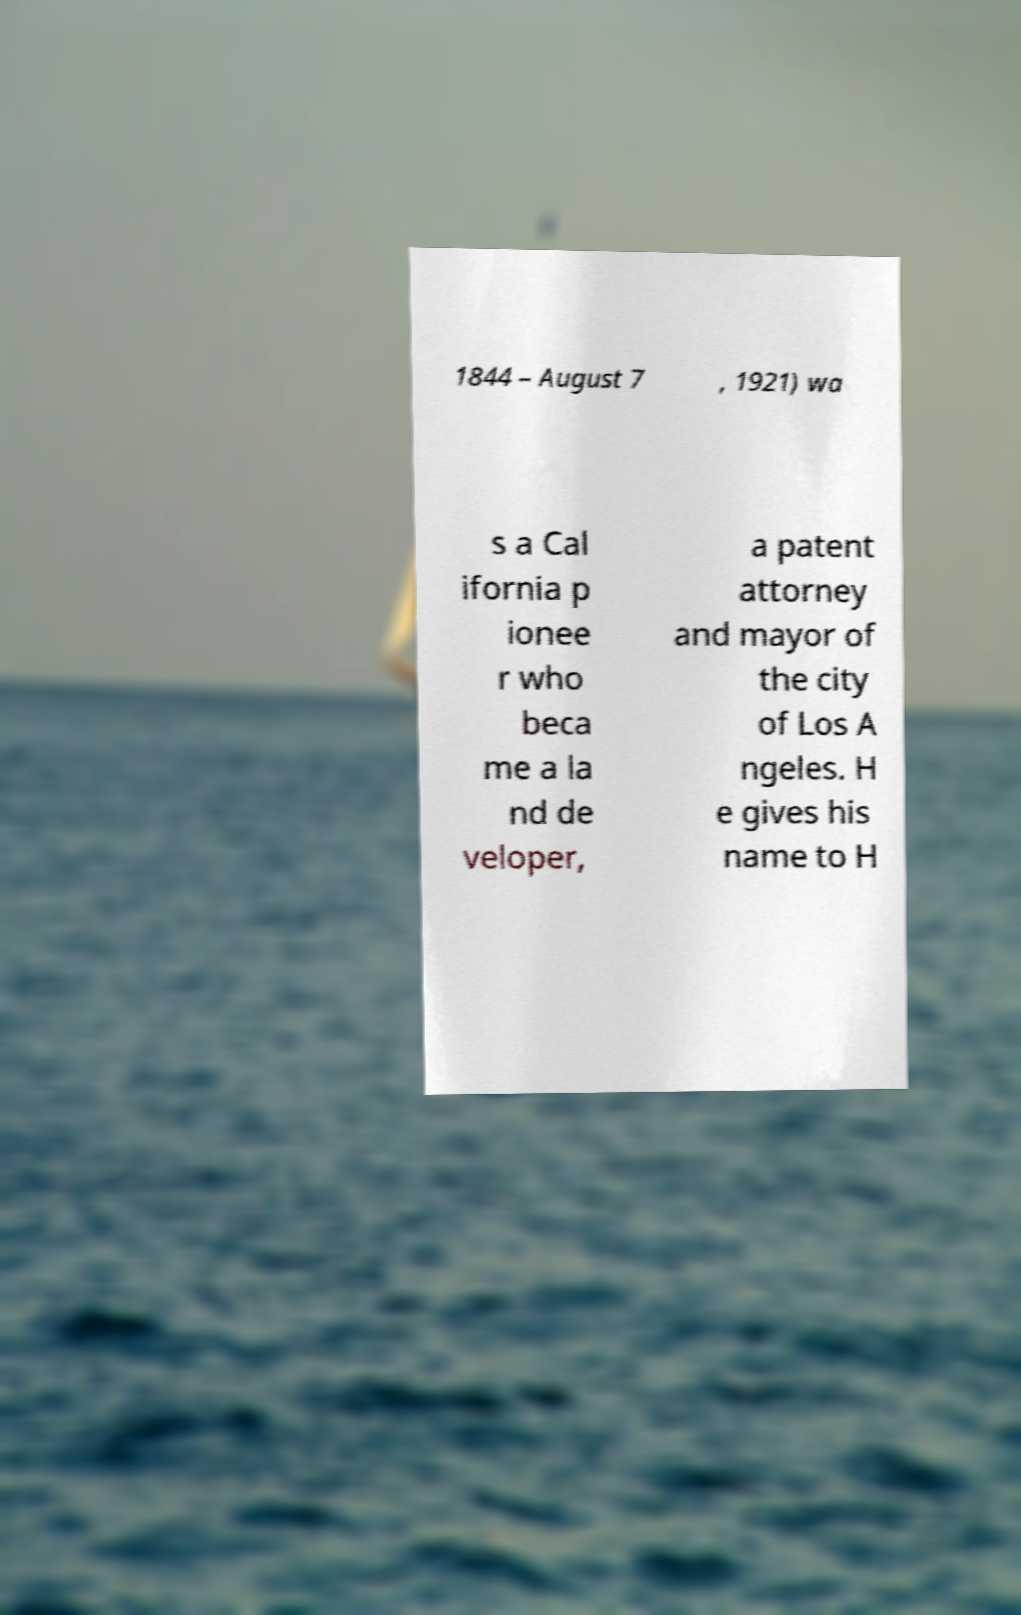Can you read and provide the text displayed in the image?This photo seems to have some interesting text. Can you extract and type it out for me? 1844 – August 7 , 1921) wa s a Cal ifornia p ionee r who beca me a la nd de veloper, a patent attorney and mayor of the city of Los A ngeles. H e gives his name to H 